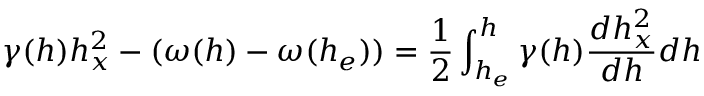Convert formula to latex. <formula><loc_0><loc_0><loc_500><loc_500>\gamma ( h ) h _ { x } ^ { 2 } - ( \omega ( h ) - \omega ( h _ { e } ) ) = \frac { 1 } { 2 } \int _ { h _ { e } } ^ { h } \gamma ( h ) \frac { d h _ { x } ^ { 2 } } { d h } d h</formula> 